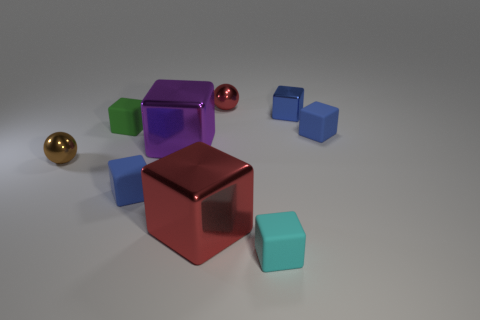Are there an equal number of matte blocks that are to the right of the green matte object and blue things that are in front of the tiny red metal thing?
Provide a short and direct response. Yes. There is a cyan rubber object; does it have the same shape as the blue rubber object that is behind the brown shiny sphere?
Give a very brief answer. Yes. What number of other objects are there of the same material as the purple cube?
Give a very brief answer. 4. There is a tiny cyan matte object; are there any large red metal blocks right of it?
Your answer should be compact. No. There is a green matte thing; is it the same size as the shiny block left of the big red metal object?
Keep it short and to the point. No. There is a metal sphere that is to the left of the small sphere that is behind the green matte thing; what color is it?
Provide a short and direct response. Brown. Does the brown object have the same size as the cyan object?
Provide a succinct answer. Yes. What is the color of the metal object that is both left of the cyan cube and behind the green rubber object?
Provide a short and direct response. Red. What size is the green object?
Provide a succinct answer. Small. Does the rubber block that is right of the cyan cube have the same color as the tiny shiny cube?
Offer a very short reply. Yes. 